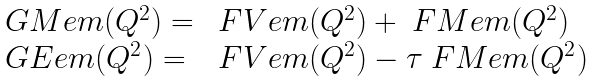<formula> <loc_0><loc_0><loc_500><loc_500>\begin{array} { l l } \ G M e m ( Q ^ { 2 } ) = & \ F V e m ( Q ^ { 2 } ) + \ F M e m ( Q ^ { 2 } ) \\ \ G E e m ( Q ^ { 2 } ) = & \ F V e m ( Q ^ { 2 } ) - \tau \ F M e m ( Q ^ { 2 } ) \end{array}</formula> 